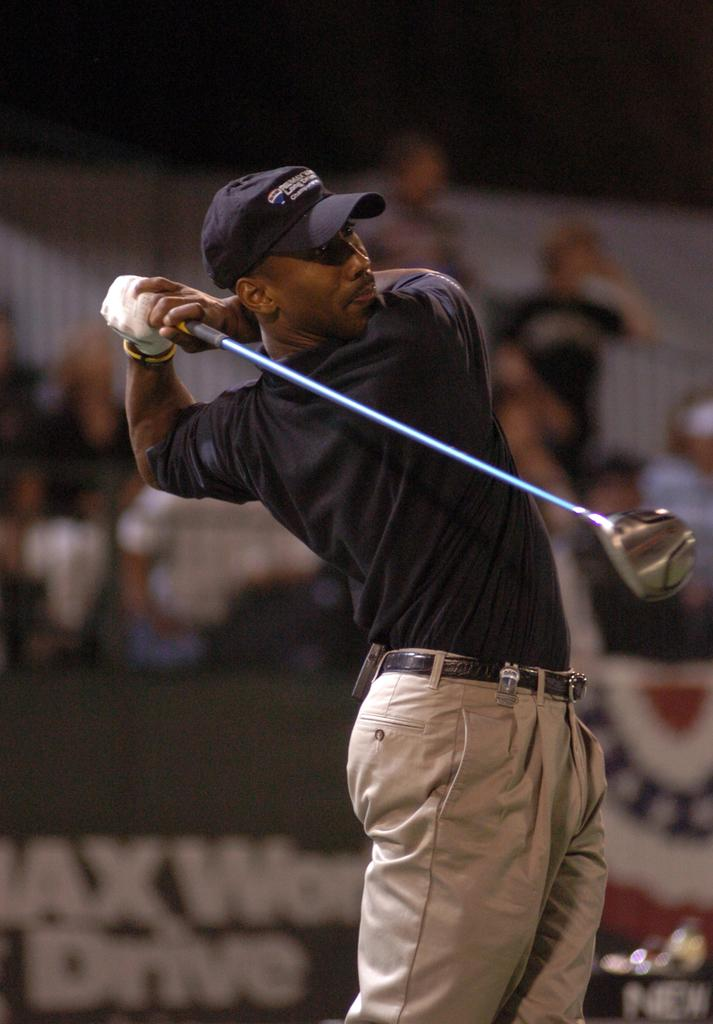Who is the main subject in the image? There is a man in the center of the image. What is the man doing in the image? The man is standing and holding a hockey stick in his hand. What can be seen in the background of the image? There are boards and people visible in the background of the image. What type of flower is the man holding in his hand? The man is not holding a flower in his hand; he is holding a hockey stick. How many chairs are visible in the image? There are no chairs visible in the image. 